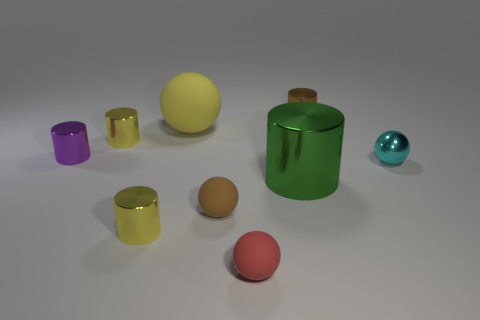What is the large green cylinder made of?
Your response must be concise. Metal. Are there fewer purple shiny things that are behind the yellow ball than tiny cylinders that are right of the tiny purple metallic thing?
Ensure brevity in your answer.  Yes. How big is the matte object behind the big metal cylinder?
Offer a terse response. Large. Is there a red ball made of the same material as the brown sphere?
Offer a very short reply. Yes. Does the purple thing have the same material as the big cylinder?
Offer a very short reply. Yes. What color is the other matte sphere that is the same size as the brown rubber ball?
Offer a terse response. Red. How many other things are there of the same shape as the tiny purple shiny object?
Provide a short and direct response. 4. Do the brown metal thing and the rubber object behind the brown matte ball have the same size?
Offer a terse response. No. How many objects are gray objects or small cyan metal things?
Offer a very short reply. 1. How many other things are there of the same size as the cyan metallic object?
Offer a very short reply. 6. 